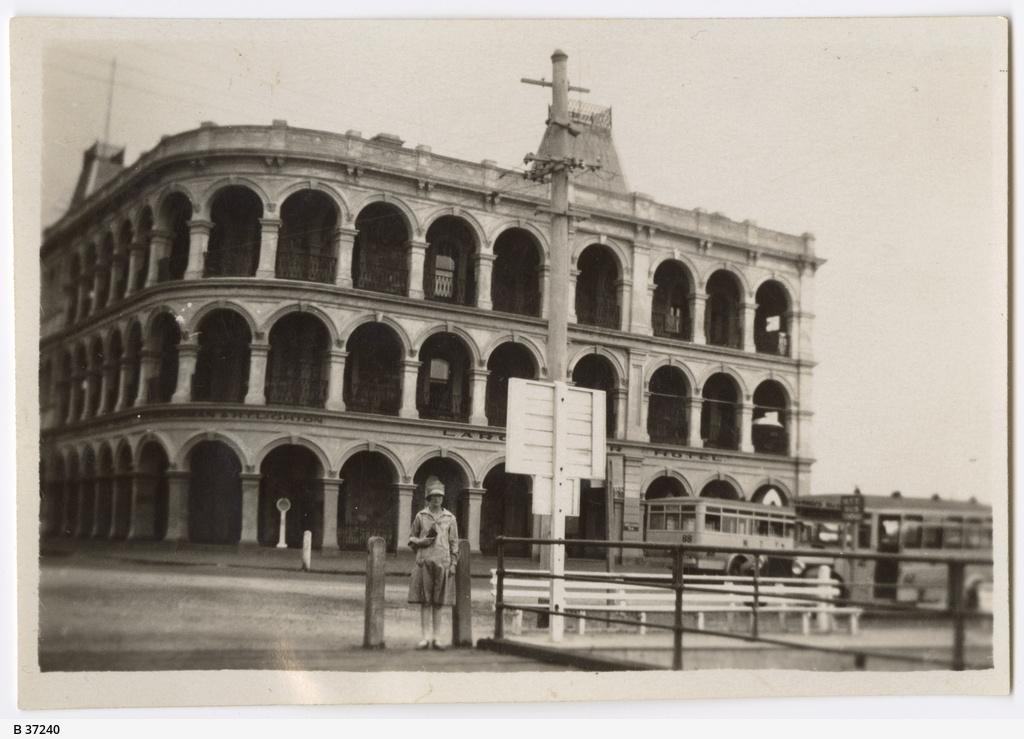What is the person in the image doing? The person is standing in the image. Where is the person located in relation to the railing? The person is standing near a railing. What can be seen attached to a pole in the image? There is a board attached to a pole in the image. What is visible in the background of the image? Vehicles, at least one building, and the sky are visible in the background of the image. What type of quartz can be seen sparkling in the image? There is no quartz present in the image. Can you hear the sound of the ladybug flying in the image? There is no ladybug present in the image, and therefore no sound can be heard. 